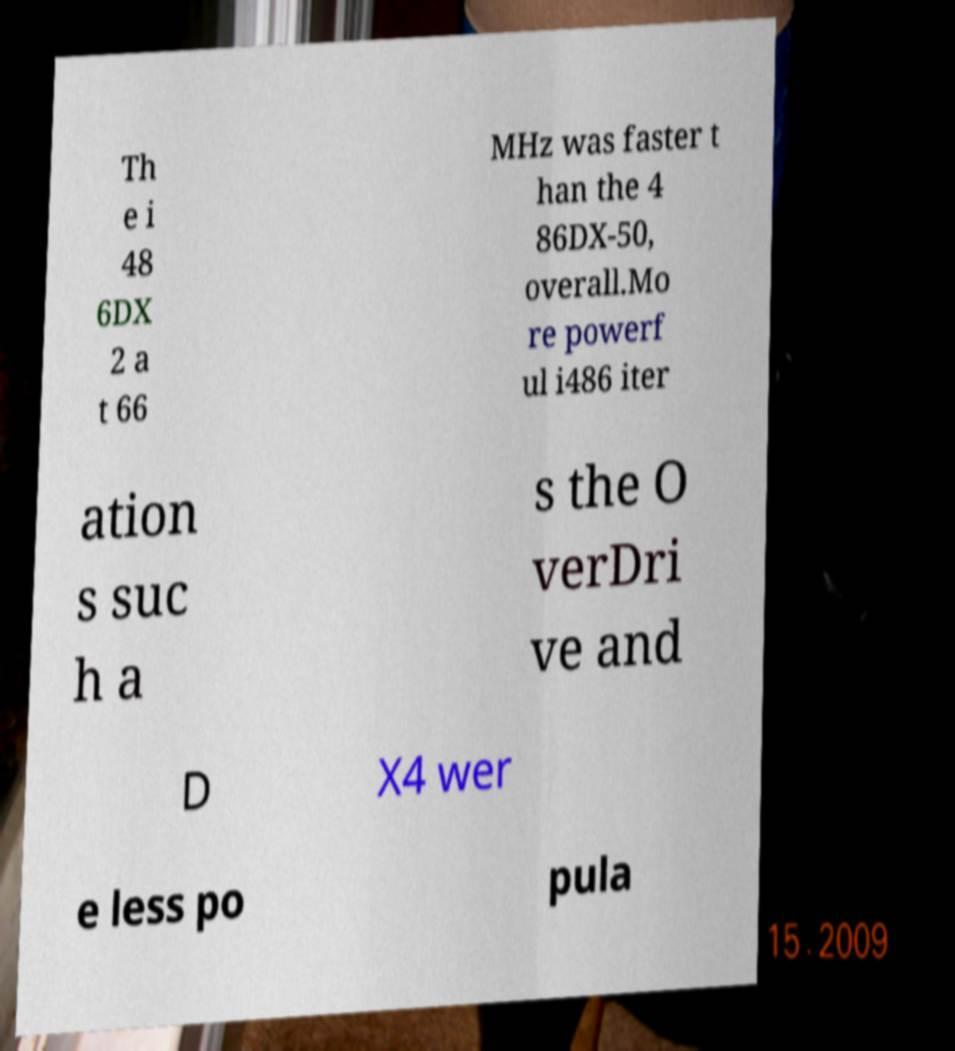There's text embedded in this image that I need extracted. Can you transcribe it verbatim? Th e i 48 6DX 2 a t 66 MHz was faster t han the 4 86DX-50, overall.Mo re powerf ul i486 iter ation s suc h a s the O verDri ve and D X4 wer e less po pula 